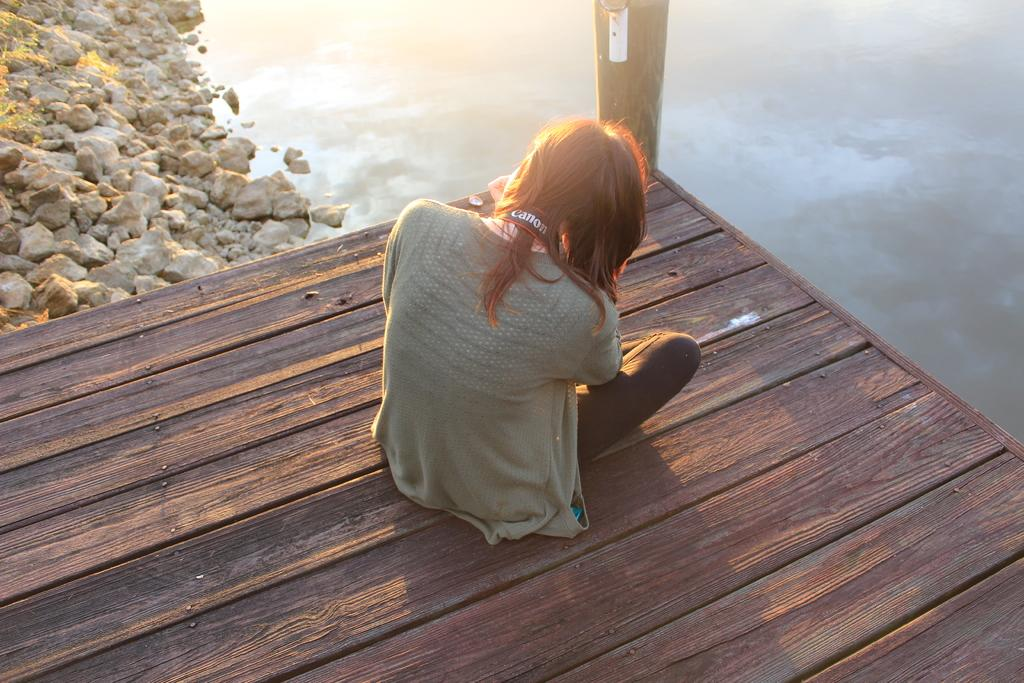What is the woman doing in the image? The woman is sitting on a bridge in the image. What can be seen near the bridge? There are stones beside the bridge. What is visible in the background of the image? Water is visible in the background of the image. What type of education does the crib in the image provide? There is no crib present in the image, so it cannot provide any education. 